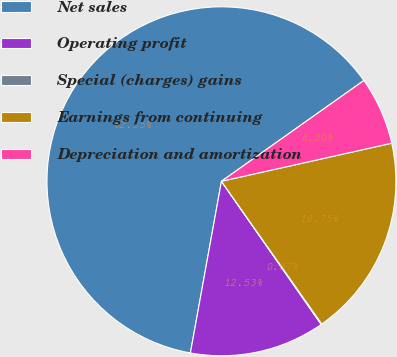Convert chart to OTSL. <chart><loc_0><loc_0><loc_500><loc_500><pie_chart><fcel>Net sales<fcel>Operating profit<fcel>Special (charges) gains<fcel>Earnings from continuing<fcel>Depreciation and amortization<nl><fcel>62.35%<fcel>12.53%<fcel>0.07%<fcel>18.75%<fcel>6.3%<nl></chart> 